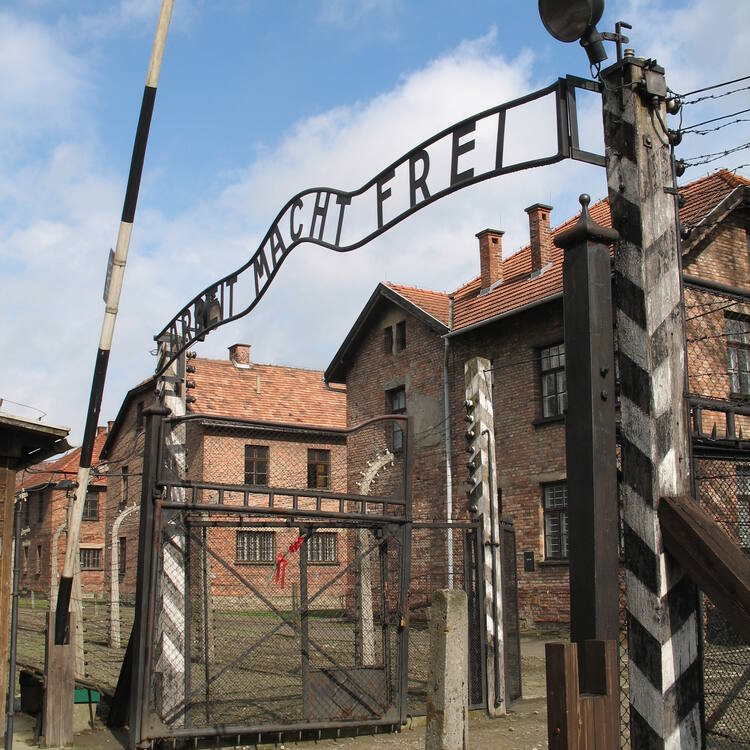Describe a day in the life of a prisoner in Auschwitz based on the image. A day in the life of a prisoner in Auschwitz, as reflected by the image, would begin in the early hours of the morning, often before sunrise. The day would start with harsh wake-up calls, followed by the forced march through the gate adorned with the deceptive inscription "Arbeit Macht Frei". Prisoners would be subjected to grueling forced labor under constant supervision, often tasked with construction, manufacturing, or other physically demanding work under appalling conditions. Throughout the day, they would endure brutal treatment from the guards, inadequate food rations, and exposure to extreme weather conditions, whether scorching hot or freezing cold. Emotional and physical exhaustion would hang heavily over the camp, and every moment would be a fight for survival against disease, starvation, and despair. The day would end just as harshly as it began, with prisoners returning to overcrowded barracks, often too exhausted to even eat, falling into restless sleep filled with nightmares of their reality. 